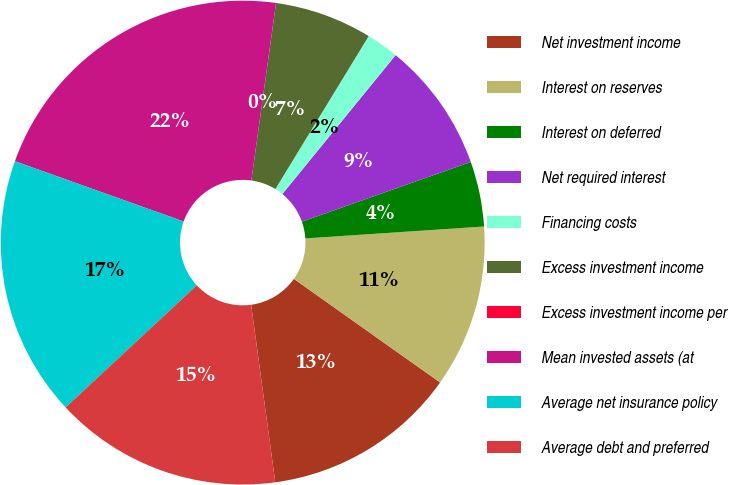Convert chart. <chart><loc_0><loc_0><loc_500><loc_500><pie_chart><fcel>Net investment income<fcel>Interest on reserves<fcel>Interest on deferred<fcel>Net required interest<fcel>Financing costs<fcel>Excess investment income<fcel>Excess investment income per<fcel>Mean invested assets (at<fcel>Average net insurance policy<fcel>Average debt and preferred<nl><fcel>13.04%<fcel>10.87%<fcel>4.35%<fcel>8.7%<fcel>2.17%<fcel>6.52%<fcel>0.0%<fcel>21.74%<fcel>17.39%<fcel>15.22%<nl></chart> 